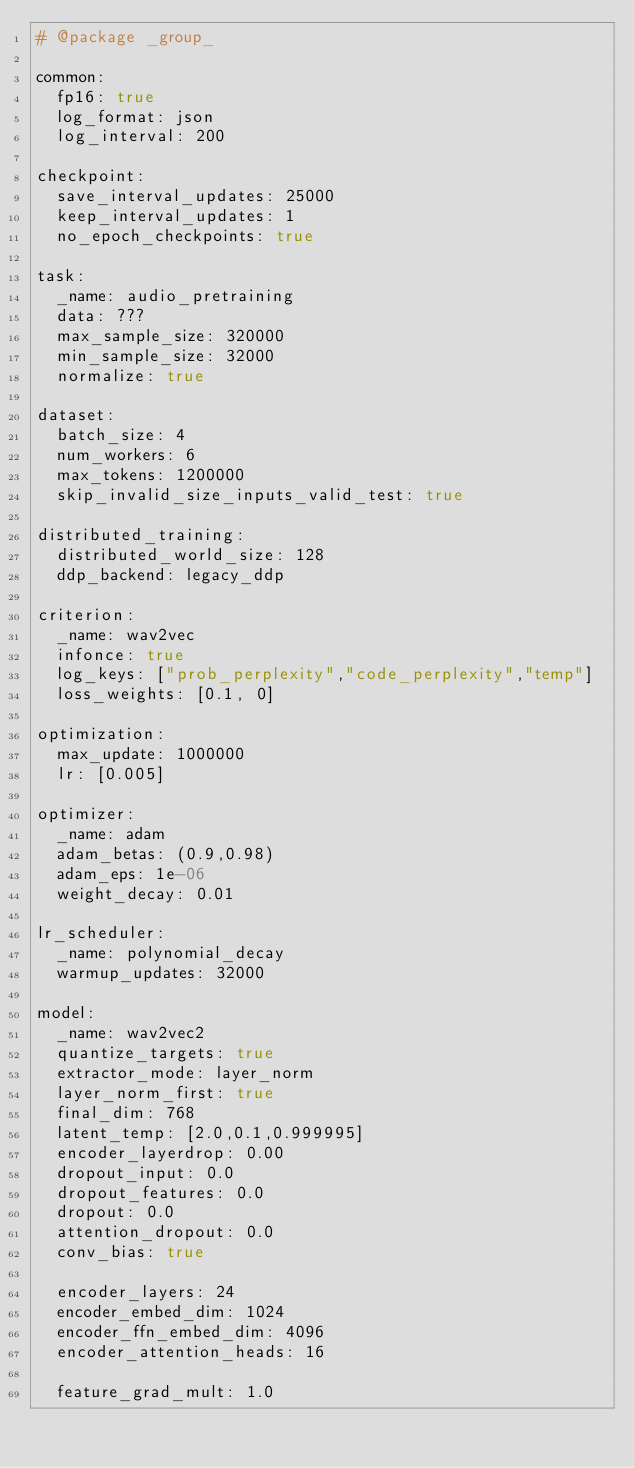Convert code to text. <code><loc_0><loc_0><loc_500><loc_500><_YAML_># @package _group_

common:
  fp16: true
  log_format: json
  log_interval: 200

checkpoint:
  save_interval_updates: 25000
  keep_interval_updates: 1
  no_epoch_checkpoints: true

task:
  _name: audio_pretraining
  data: ???
  max_sample_size: 320000
  min_sample_size: 32000
  normalize: true

dataset:
  batch_size: 4
  num_workers: 6
  max_tokens: 1200000
  skip_invalid_size_inputs_valid_test: true

distributed_training:
  distributed_world_size: 128
  ddp_backend: legacy_ddp

criterion:
  _name: wav2vec
  infonce: true
  log_keys: ["prob_perplexity","code_perplexity","temp"]
  loss_weights: [0.1, 0]

optimization:
  max_update: 1000000
  lr: [0.005]

optimizer:
  _name: adam
  adam_betas: (0.9,0.98)
  adam_eps: 1e-06
  weight_decay: 0.01

lr_scheduler:
  _name: polynomial_decay
  warmup_updates: 32000

model:
  _name: wav2vec2
  quantize_targets: true
  extractor_mode: layer_norm
  layer_norm_first: true
  final_dim: 768
  latent_temp: [2.0,0.1,0.999995]
  encoder_layerdrop: 0.00
  dropout_input: 0.0
  dropout_features: 0.0
  dropout: 0.0
  attention_dropout: 0.0
  conv_bias: true

  encoder_layers: 24
  encoder_embed_dim: 1024
  encoder_ffn_embed_dim: 4096
  encoder_attention_heads: 16

  feature_grad_mult: 1.0

</code> 